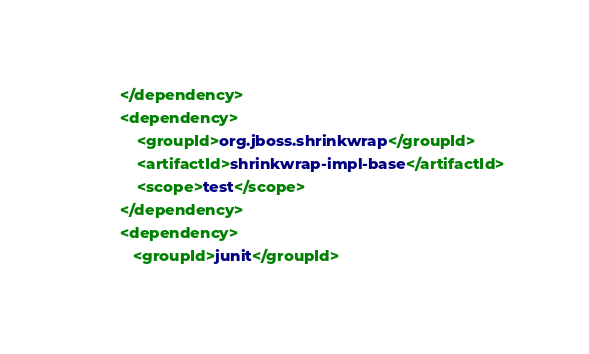Convert code to text. <code><loc_0><loc_0><loc_500><loc_500><_XML_>        </dependency>
        <dependency>
            <groupId>org.jboss.shrinkwrap</groupId>
            <artifactId>shrinkwrap-impl-base</artifactId>
            <scope>test</scope>
        </dependency>
        <dependency>
           <groupId>junit</groupId></code> 